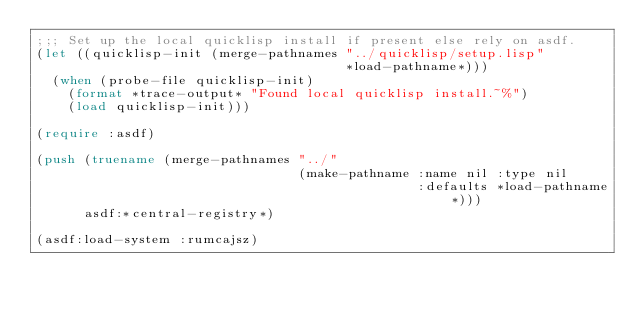Convert code to text. <code><loc_0><loc_0><loc_500><loc_500><_Lisp_>;;; Set up the local quicklisp install if present else rely on asdf.
(let ((quicklisp-init (merge-pathnames "../quicklisp/setup.lisp"
                                       *load-pathname*)))
  (when (probe-file quicklisp-init)
    (format *trace-output* "Found local quicklisp install.~%")
    (load quicklisp-init)))

(require :asdf)

(push (truename (merge-pathnames "../"
                                 (make-pathname :name nil :type nil
                                                :defaults *load-pathname*)))
      asdf:*central-registry*)

(asdf:load-system :rumcajsz)
</code> 